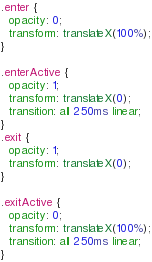<code> <loc_0><loc_0><loc_500><loc_500><_CSS_>.enter {
  opacity: 0;
  transform: translateX(100%);
}

.enterActive {
  opacity: 1;
  transform: translateX(0);
  transition: all 250ms linear;
}
.exit {
  opacity: 1;
  transform: translateX(0);
}

.exitActive {
  opacity: 0;
  transform: translateX(100%);
  transition: all 250ms linear;
}
</code> 